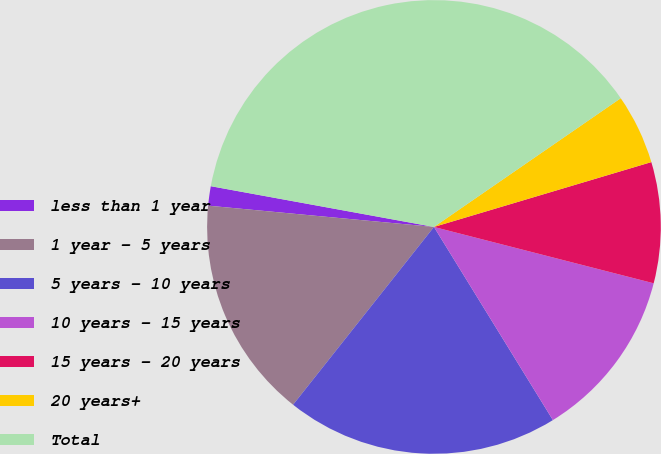Convert chart to OTSL. <chart><loc_0><loc_0><loc_500><loc_500><pie_chart><fcel>less than 1 year<fcel>1 year - 5 years<fcel>5 years - 10 years<fcel>10 years - 15 years<fcel>15 years - 20 years<fcel>20 years+<fcel>Total<nl><fcel>1.38%<fcel>15.83%<fcel>19.45%<fcel>12.22%<fcel>8.61%<fcel>4.99%<fcel>37.52%<nl></chart> 